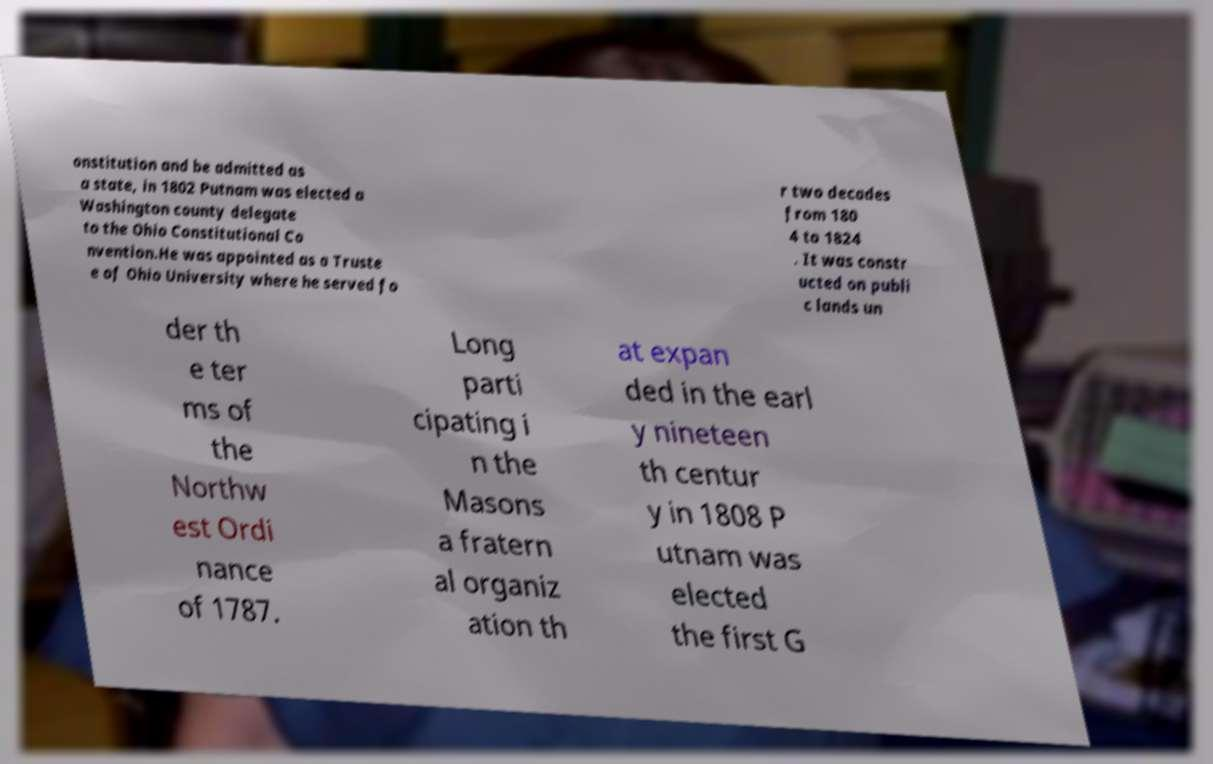I need the written content from this picture converted into text. Can you do that? onstitution and be admitted as a state, in 1802 Putnam was elected a Washington county delegate to the Ohio Constitutional Co nvention.He was appointed as a Truste e of Ohio University where he served fo r two decades from 180 4 to 1824 . It was constr ucted on publi c lands un der th e ter ms of the Northw est Ordi nance of 1787. Long parti cipating i n the Masons a fratern al organiz ation th at expan ded in the earl y nineteen th centur y in 1808 P utnam was elected the first G 